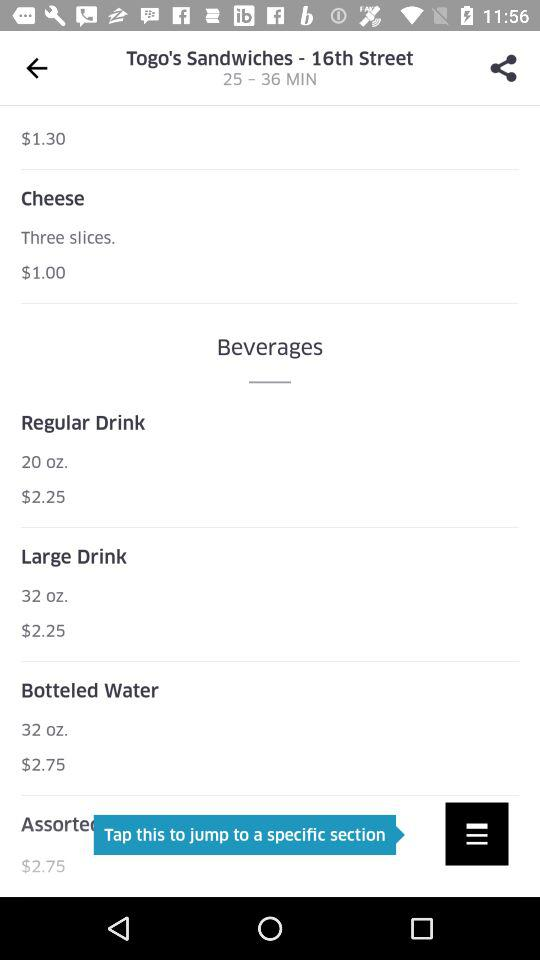What's the price of "Botteled Water"? The price of "Botteled Water" is $2.75. 